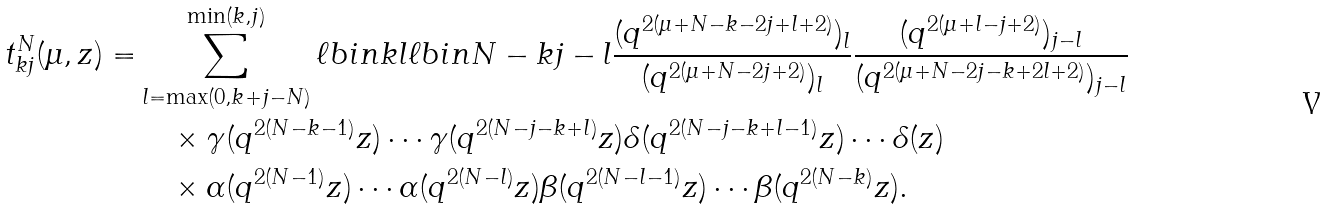<formula> <loc_0><loc_0><loc_500><loc_500>t ^ { N } _ { k j } ( \mu , z ) = & \sum _ { l = \max ( 0 , k + j - N ) } ^ { \min ( k , j ) } \ell b i n { k } { l } \ell b i n { N - k } { j - l } \frac { ( q ^ { 2 ( \mu + N - k - 2 j + l + 2 ) } ) _ { l } } { ( q ^ { 2 ( \mu + N - 2 j + 2 ) } ) _ { l } } \frac { ( q ^ { 2 ( \mu + l - j + 2 ) } ) _ { j - l } } { ( q ^ { 2 ( \mu + N - 2 j - k + 2 l + 2 ) } ) _ { j - l } } \\ & \quad \times \gamma ( q ^ { 2 ( N - k - 1 ) } z ) \cdots \gamma ( q ^ { 2 ( N - j - k + l ) } z ) \delta ( q ^ { 2 ( N - j - k + l - 1 ) } z ) \cdots \delta ( z ) \\ & \quad \times \alpha ( q ^ { 2 ( N - 1 ) } z ) \cdots \alpha ( q ^ { 2 ( N - l ) } z ) \beta ( q ^ { 2 ( N - l - 1 ) } z ) \cdots \beta ( q ^ { 2 ( N - k ) } z ) .</formula> 